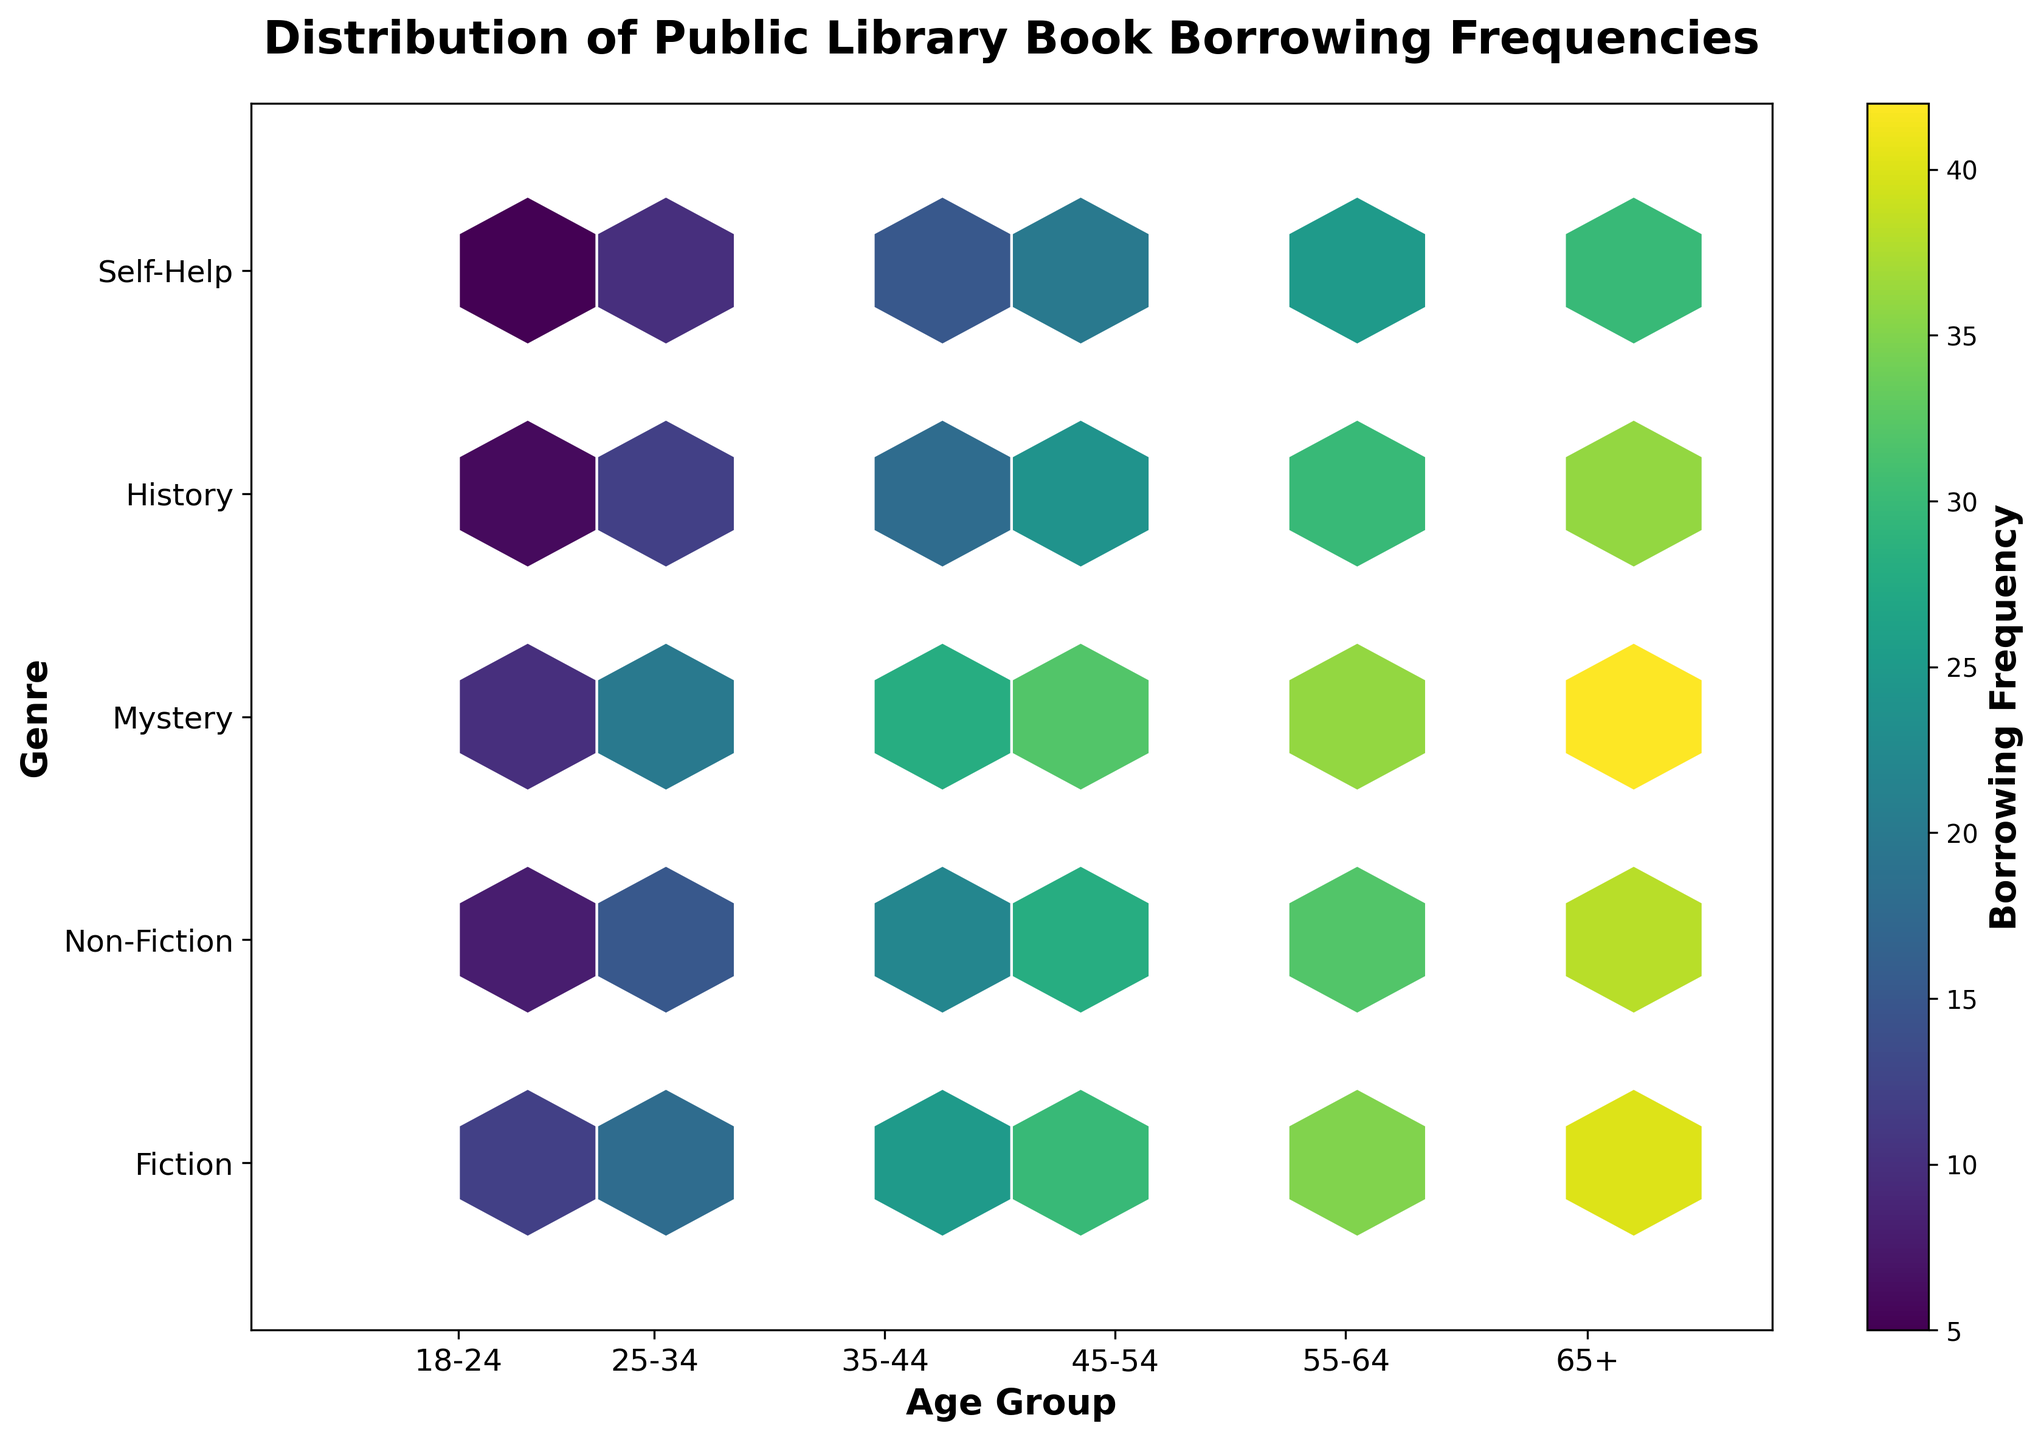What is the title of the plot? The title is usually located at the top of the plot. In this case, it reads, "Distribution of Public Library Book Borrowing Frequencies."
Answer: Distribution of Public Library Book Borrowing Frequencies What genres of books are included in the plot? The genres are listed along the y-axis. They are "Fiction," "Non-Fiction," "Mystery," "History," and "Self-Help."
Answer: Fiction, Non-Fiction, Mystery, History, Self-Help Which age group has the highest borrowing frequency for Fiction books? Along the y-axis, find the row labeled "Fiction." Scan across this row to find the hexbin with the highest color intensity, then correlate to the corresponding age group on the x-axis. The highest borrowing frequency for Fiction is at the "65+" age group.
Answer: 65+ What is the borrowing frequency for Non-Fiction books in the 25-34 age group? Locate the "Non-Fiction" row on the y-axis and the "25-34" group on the x-axis. The color intensity and the color bar indicate that the borrowing frequency is 15.
Answer: 15 Which genre shows the most significant increase in borrowing frequencies from age group 18-24 to 65+? Observe each genre row from the 18-24 age group x-axis to the 65+ age group. Compare the color intensities. Mystery shows a consistent and substantial increase in borrowing frequencies, going from a lower color intensity to a much higher one.
Answer: Mystery How does the borrowing frequency for History books compare between the 18-24 and 45-54 age groups? Locate the "History" row and compare the hexbin color intensities between the "18-24" and "45-54" age groups. The frequency increases from 6 to 24, as indicated by a significant rise in color intensity.
Answer: Borrowing frequency for History increases from 6 to 24 What age group has the lowest borrowing frequency for Self-Help books? Locate the "Self-Help" row on the y-axis. Identify the hexbin with the least color intensity and correlate it to the x-axis age group labels. The "18-24" age group has the lowest borrowing frequency.
Answer: 18-24 In which age group does Mystery books' borrowing frequency equal 10? Find the hexbin with the intensity that corresponds to 10 in the "Mystery" row on the y-axis and correlate it to the x-axis. This occurs in the "18-24" age group.
Answer: 18-24 Which genre generally has the highest borrowing frequencies across all age groups? Look at the overall color intensities across rows for each genre. Fiction consistently has the highest borrowing frequencies, indicated by higher color intensities throughout the age groups.
Answer: Fiction 